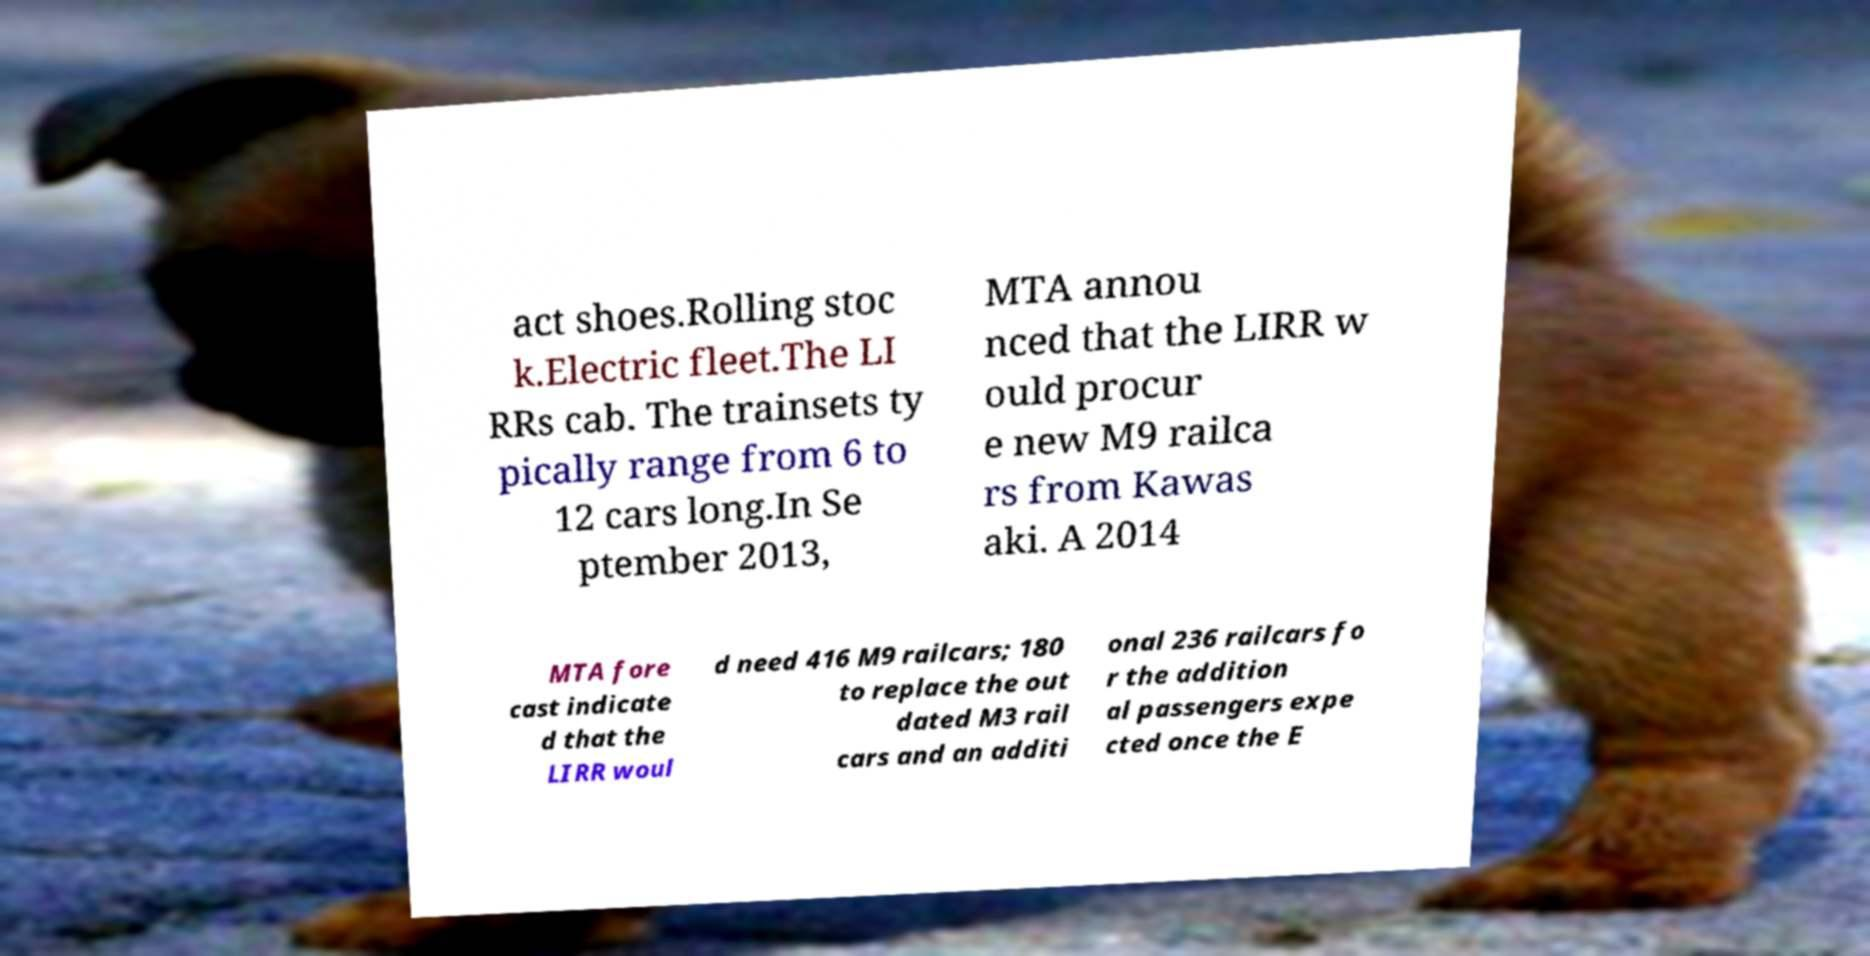Could you assist in decoding the text presented in this image and type it out clearly? act shoes.Rolling stoc k.Electric fleet.The LI RRs cab. The trainsets ty pically range from 6 to 12 cars long.In Se ptember 2013, MTA annou nced that the LIRR w ould procur e new M9 railca rs from Kawas aki. A 2014 MTA fore cast indicate d that the LIRR woul d need 416 M9 railcars; 180 to replace the out dated M3 rail cars and an additi onal 236 railcars fo r the addition al passengers expe cted once the E 